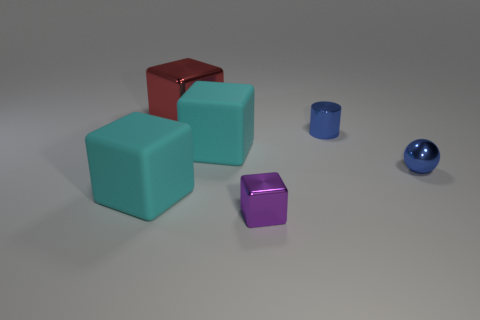The shiny cylinder that is the same size as the purple metal block is what color?
Offer a terse response. Blue. There is a small blue metal thing behind the large matte object behind the rubber thing on the left side of the red thing; what shape is it?
Give a very brief answer. Cylinder. There is a thing that is the same color as the small sphere; what is its shape?
Your answer should be very brief. Cylinder. What number of things are either tiny blue metallic spheres or big cubes to the left of the large red metallic thing?
Ensure brevity in your answer.  2. Is the size of the metal thing left of the purple cube the same as the ball?
Give a very brief answer. No. What is the material of the blue cylinder left of the small blue ball?
Your response must be concise. Metal. Are there the same number of tiny metal blocks behind the purple thing and big cyan blocks behind the blue cylinder?
Offer a terse response. Yes. The other metallic thing that is the same shape as the red object is what color?
Offer a very short reply. Purple. Is there any other thing that has the same color as the tiny shiny ball?
Make the answer very short. Yes. How many matte things are either large blocks or blue things?
Offer a very short reply. 2. 